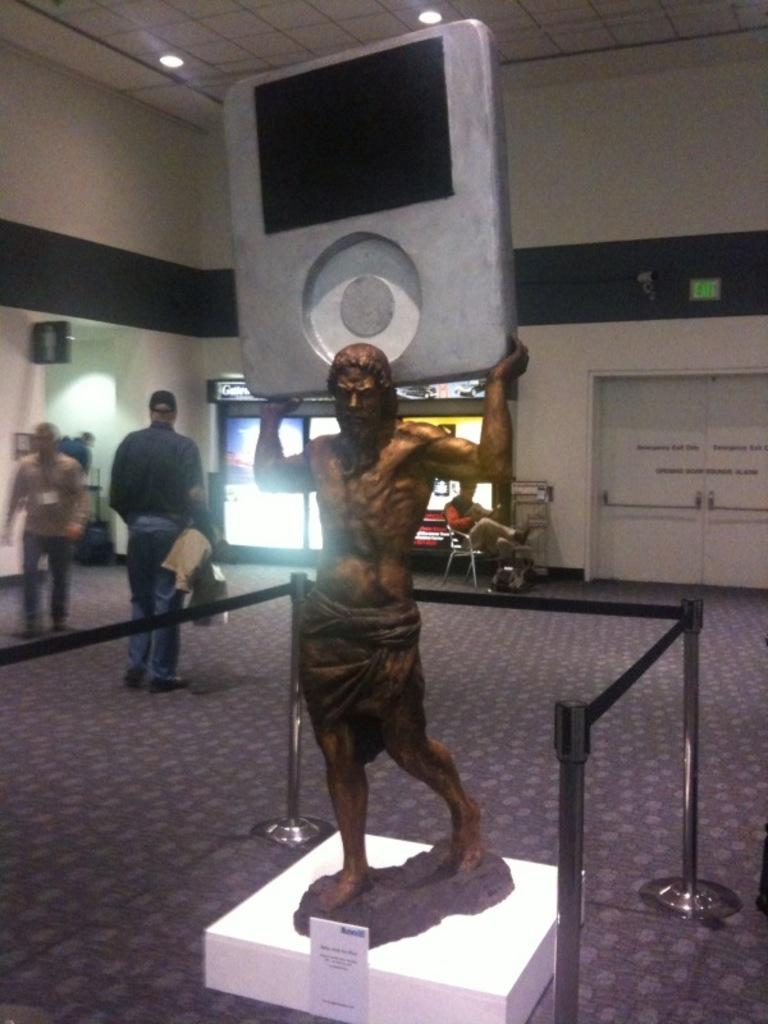What is the main subject in the image? There is a statue in the image. What is surrounding the statue? The statue is surrounded by barrier poles. Can you describe the background of the image? In the background of the image, there is a person sitting on a chair, people walking on the floor, a sign board, and walls. What type of pancake is being served at the statue in the image? There is no pancake present in the image; it features a statue surrounded by barrier poles and a background with various elements. 